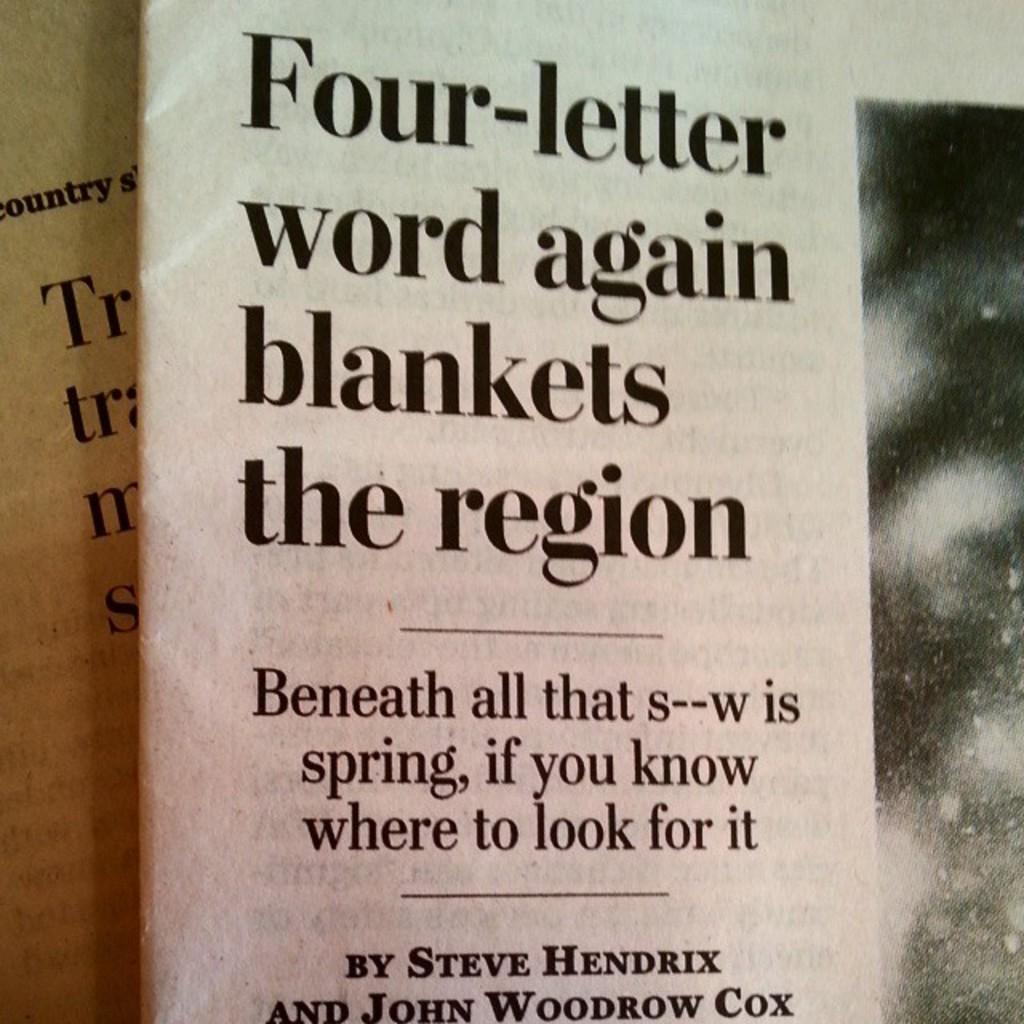<image>
Create a compact narrative representing the image presented. An article by Steve Hendrix and John Woodrow Cox is displayed. 